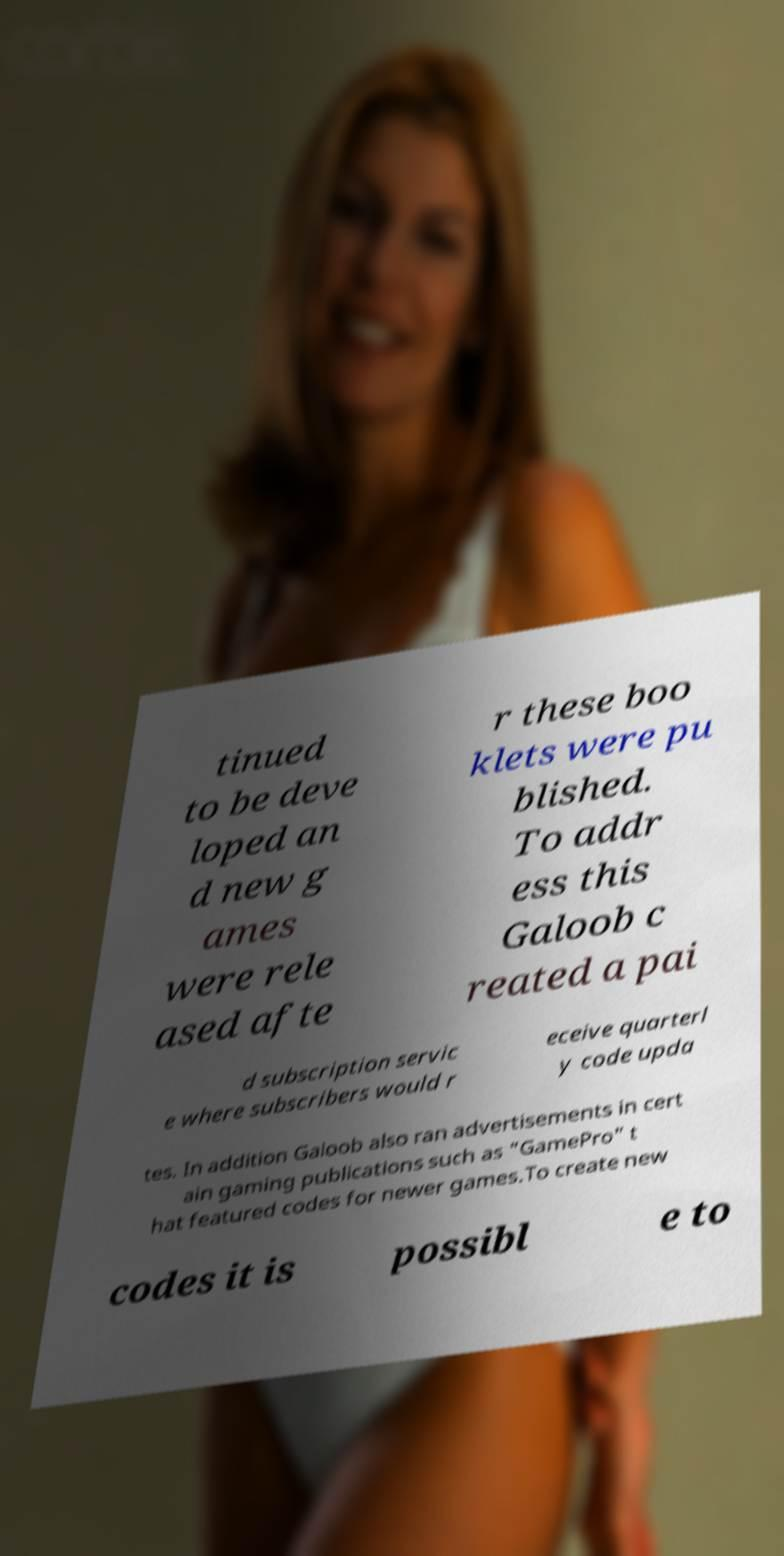Can you accurately transcribe the text from the provided image for me? tinued to be deve loped an d new g ames were rele ased afte r these boo klets were pu blished. To addr ess this Galoob c reated a pai d subscription servic e where subscribers would r eceive quarterl y code upda tes. In addition Galoob also ran advertisements in cert ain gaming publications such as "GamePro" t hat featured codes for newer games.To create new codes it is possibl e to 